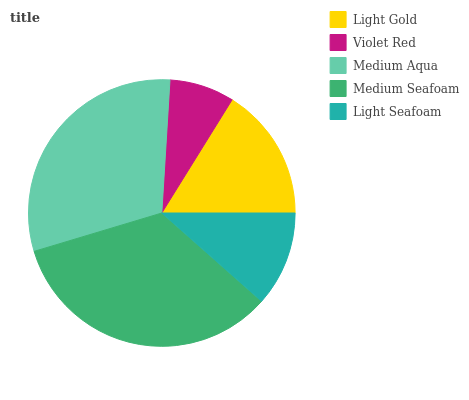Is Violet Red the minimum?
Answer yes or no. Yes. Is Medium Seafoam the maximum?
Answer yes or no. Yes. Is Medium Aqua the minimum?
Answer yes or no. No. Is Medium Aqua the maximum?
Answer yes or no. No. Is Medium Aqua greater than Violet Red?
Answer yes or no. Yes. Is Violet Red less than Medium Aqua?
Answer yes or no. Yes. Is Violet Red greater than Medium Aqua?
Answer yes or no. No. Is Medium Aqua less than Violet Red?
Answer yes or no. No. Is Light Gold the high median?
Answer yes or no. Yes. Is Light Gold the low median?
Answer yes or no. Yes. Is Medium Seafoam the high median?
Answer yes or no. No. Is Violet Red the low median?
Answer yes or no. No. 